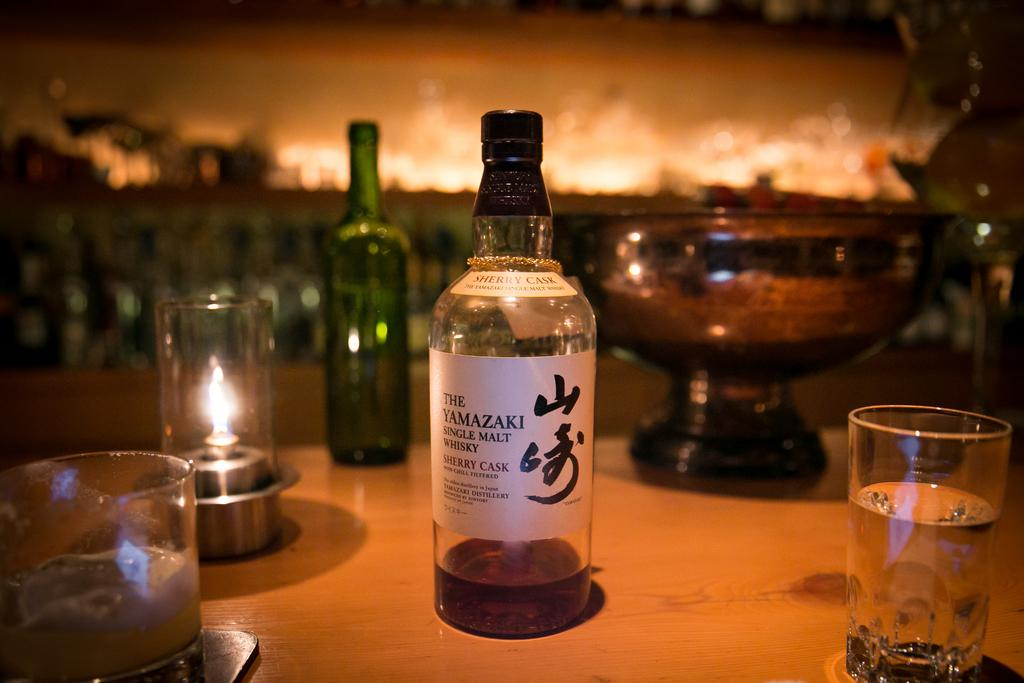What type of furniture is present in the image? There is a table in the image. What is placed on the table? There are many bottles and glass items on the table. What type of toy can be seen sliding down the slope in the image? There is no toy or slope present in the image; it only features a table with bottles and glass items. 